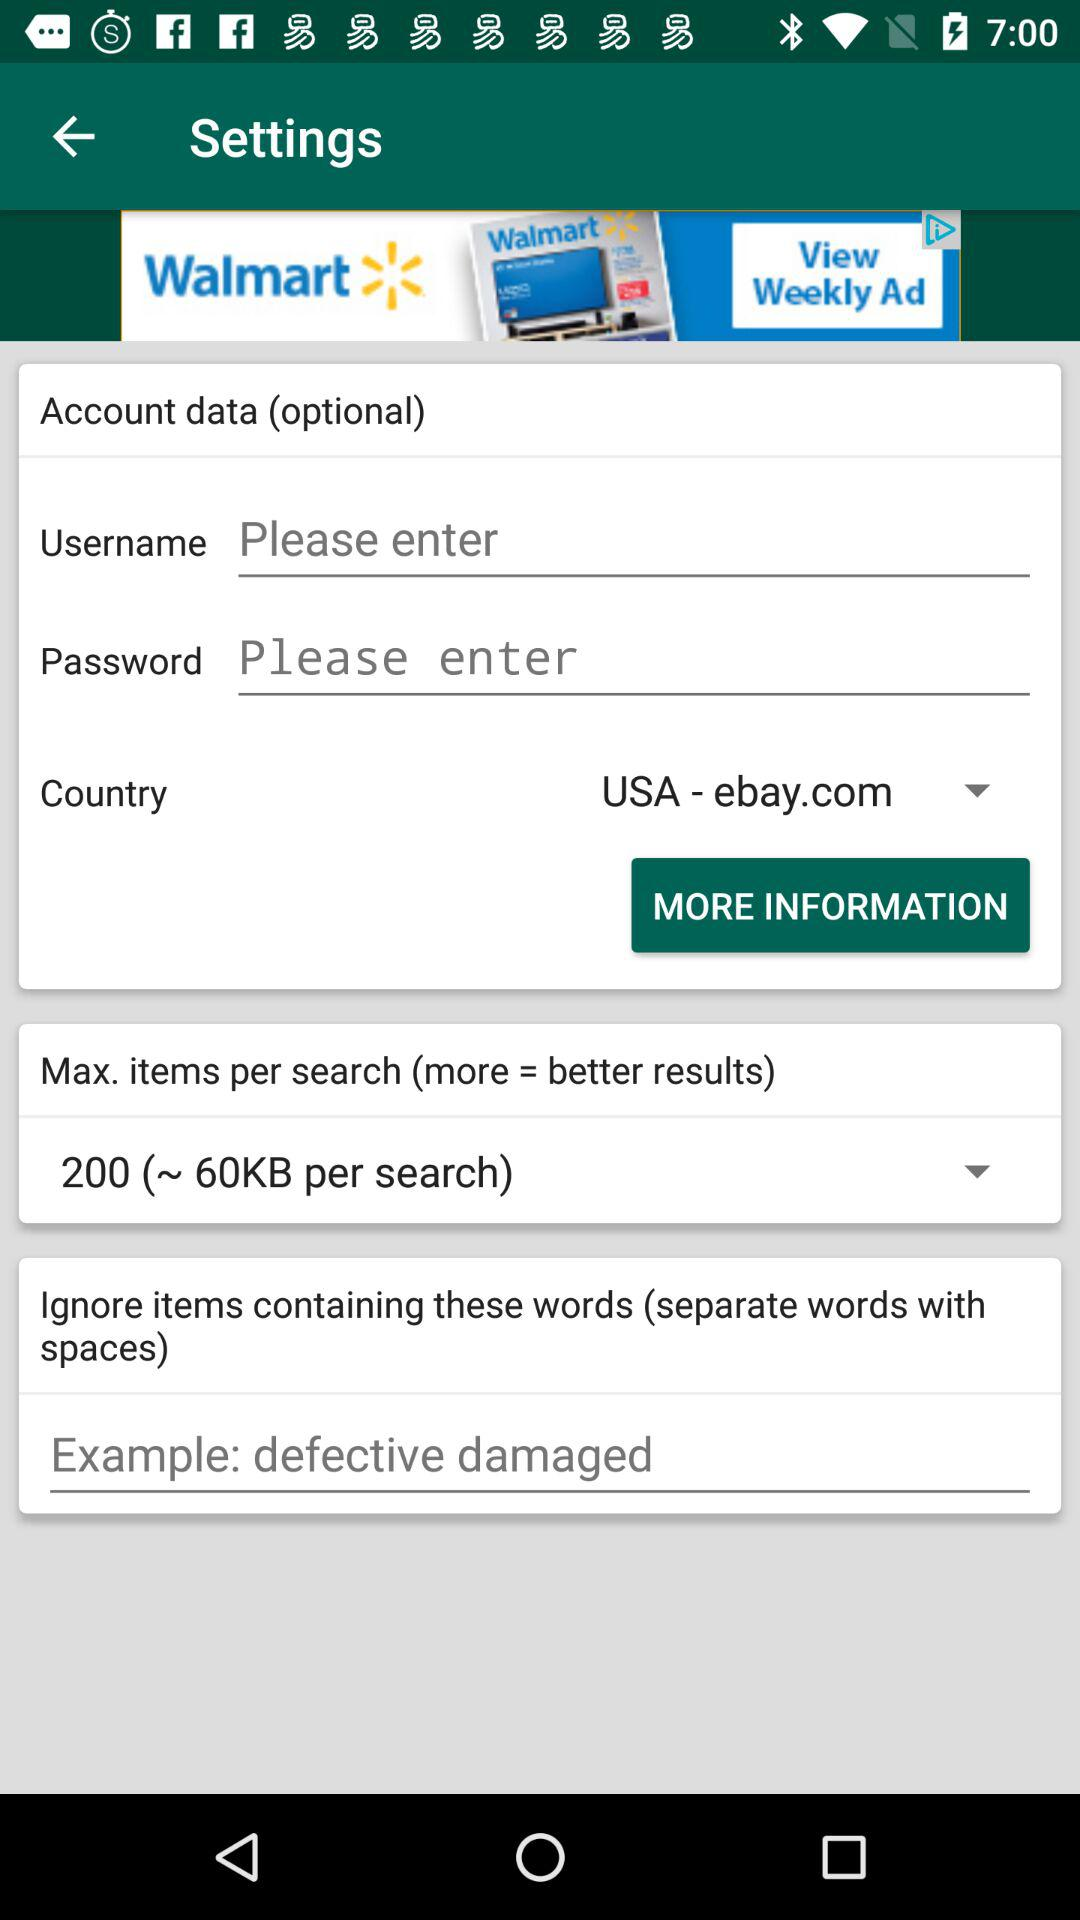What are the maximum items per search? The maximum items per search is 200. 